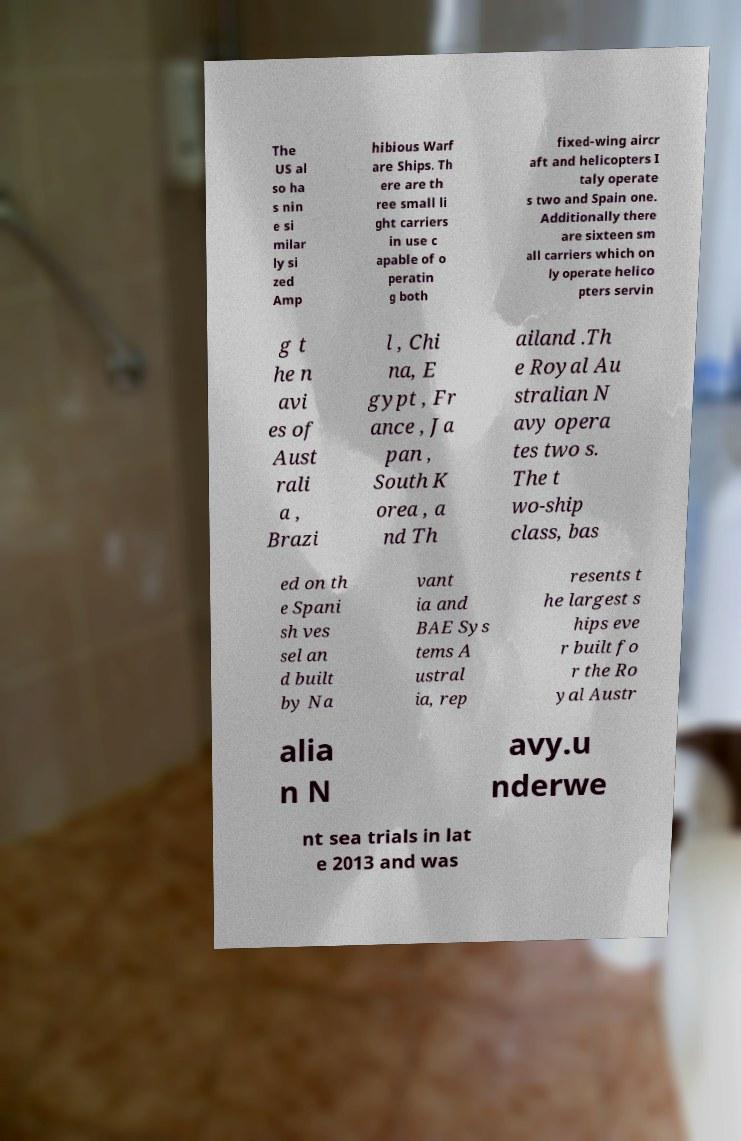Please identify and transcribe the text found in this image. The US al so ha s nin e si milar ly si zed Amp hibious Warf are Ships. Th ere are th ree small li ght carriers in use c apable of o peratin g both fixed-wing aircr aft and helicopters I taly operate s two and Spain one. Additionally there are sixteen sm all carriers which on ly operate helico pters servin g t he n avi es of Aust rali a , Brazi l , Chi na, E gypt , Fr ance , Ja pan , South K orea , a nd Th ailand .Th e Royal Au stralian N avy opera tes two s. The t wo-ship class, bas ed on th e Spani sh ves sel an d built by Na vant ia and BAE Sys tems A ustral ia, rep resents t he largest s hips eve r built fo r the Ro yal Austr alia n N avy.u nderwe nt sea trials in lat e 2013 and was 